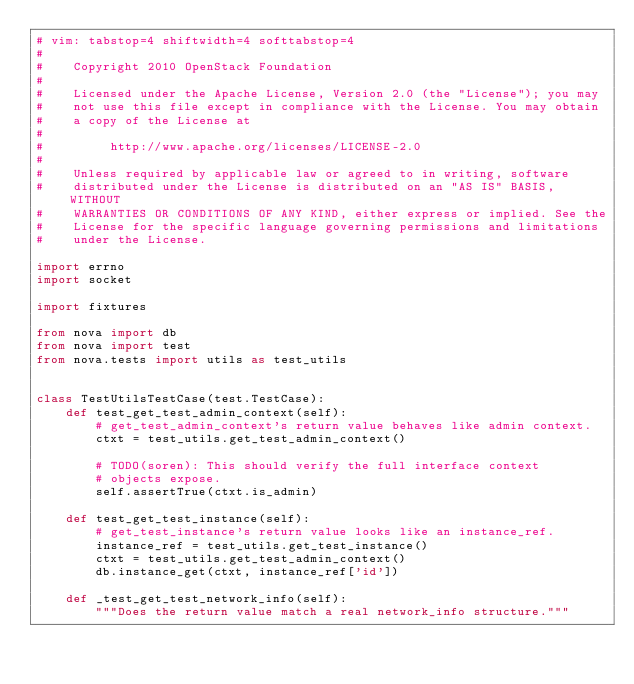<code> <loc_0><loc_0><loc_500><loc_500><_Python_># vim: tabstop=4 shiftwidth=4 softtabstop=4
#
#    Copyright 2010 OpenStack Foundation
#
#    Licensed under the Apache License, Version 2.0 (the "License"); you may
#    not use this file except in compliance with the License. You may obtain
#    a copy of the License at
#
#         http://www.apache.org/licenses/LICENSE-2.0
#
#    Unless required by applicable law or agreed to in writing, software
#    distributed under the License is distributed on an "AS IS" BASIS, WITHOUT
#    WARRANTIES OR CONDITIONS OF ANY KIND, either express or implied. See the
#    License for the specific language governing permissions and limitations
#    under the License.

import errno
import socket

import fixtures

from nova import db
from nova import test
from nova.tests import utils as test_utils


class TestUtilsTestCase(test.TestCase):
    def test_get_test_admin_context(self):
        # get_test_admin_context's return value behaves like admin context.
        ctxt = test_utils.get_test_admin_context()

        # TODO(soren): This should verify the full interface context
        # objects expose.
        self.assertTrue(ctxt.is_admin)

    def test_get_test_instance(self):
        # get_test_instance's return value looks like an instance_ref.
        instance_ref = test_utils.get_test_instance()
        ctxt = test_utils.get_test_admin_context()
        db.instance_get(ctxt, instance_ref['id'])

    def _test_get_test_network_info(self):
        """Does the return value match a real network_info structure."""</code> 